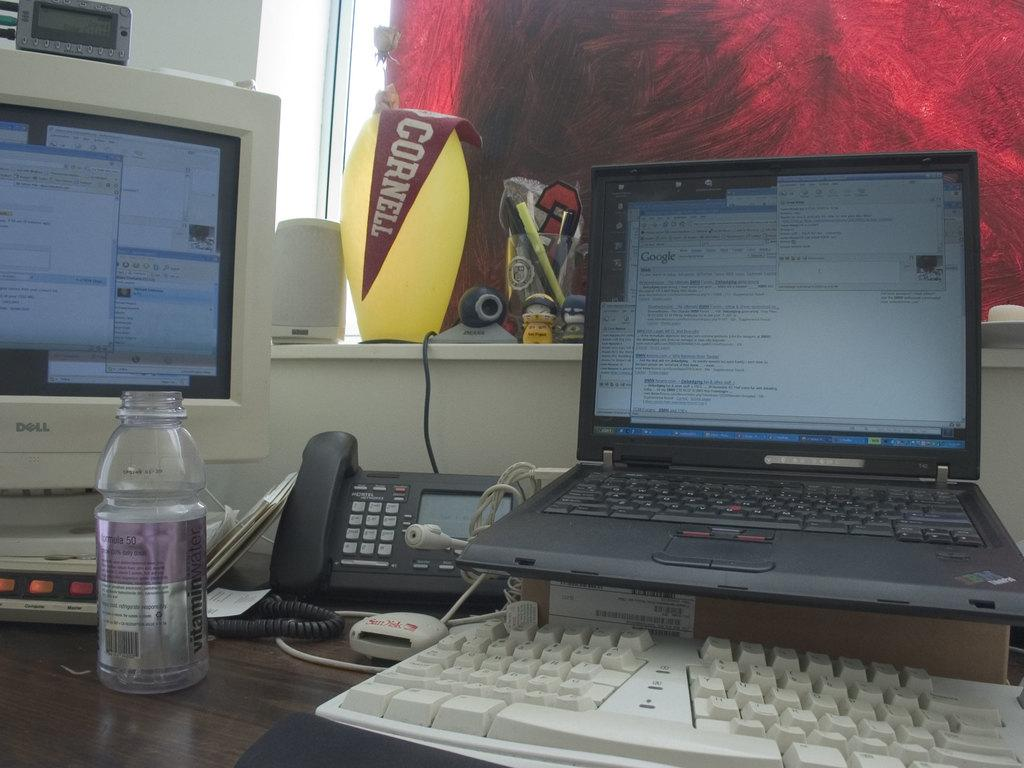<image>
Give a short and clear explanation of the subsequent image. an office setting with a cornell sign hanging on a lamp on the window sill 